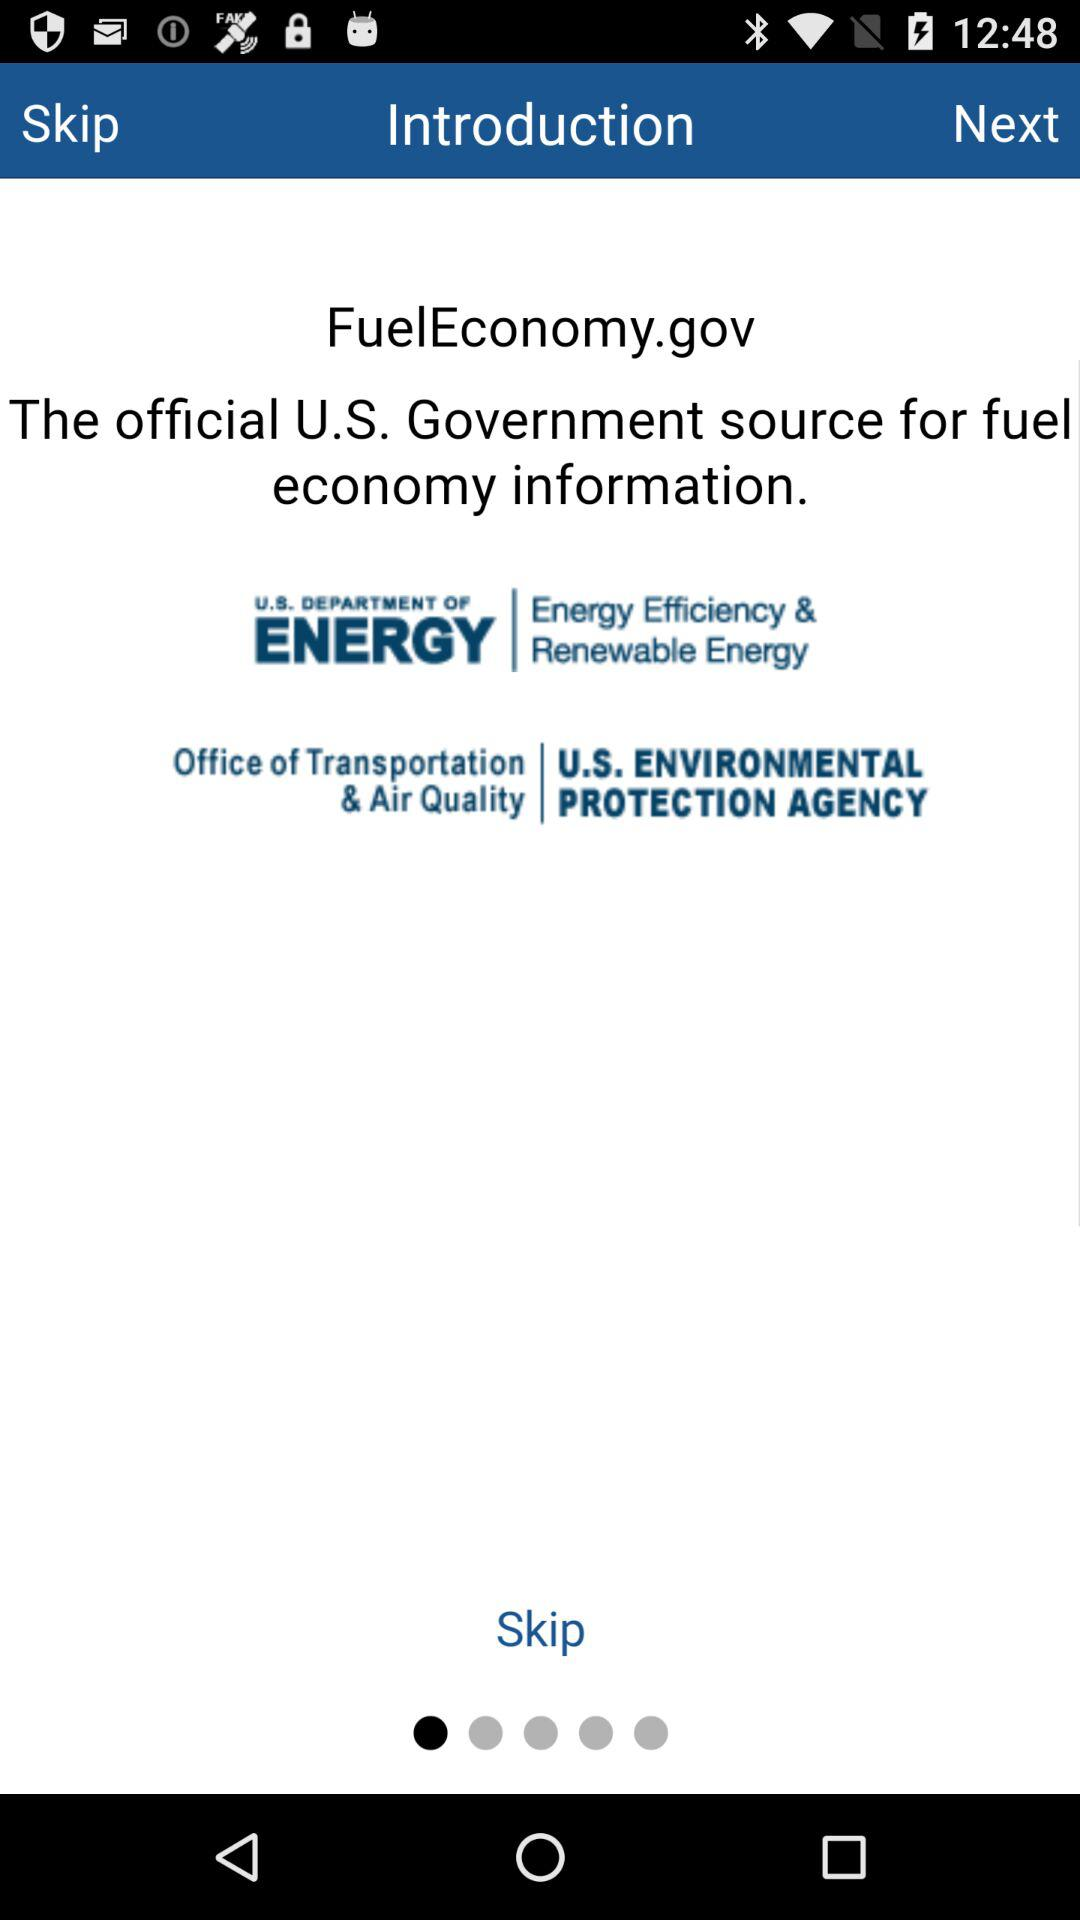How many 'U.S.'s' are in the text 'The official U.S. Government source for fuel economy information.' and 'Office of Transportation & Air Quality U.S. ENVIRONMENTAL PROTECTION AGENCY' combined?
Answer the question using a single word or phrase. 3 